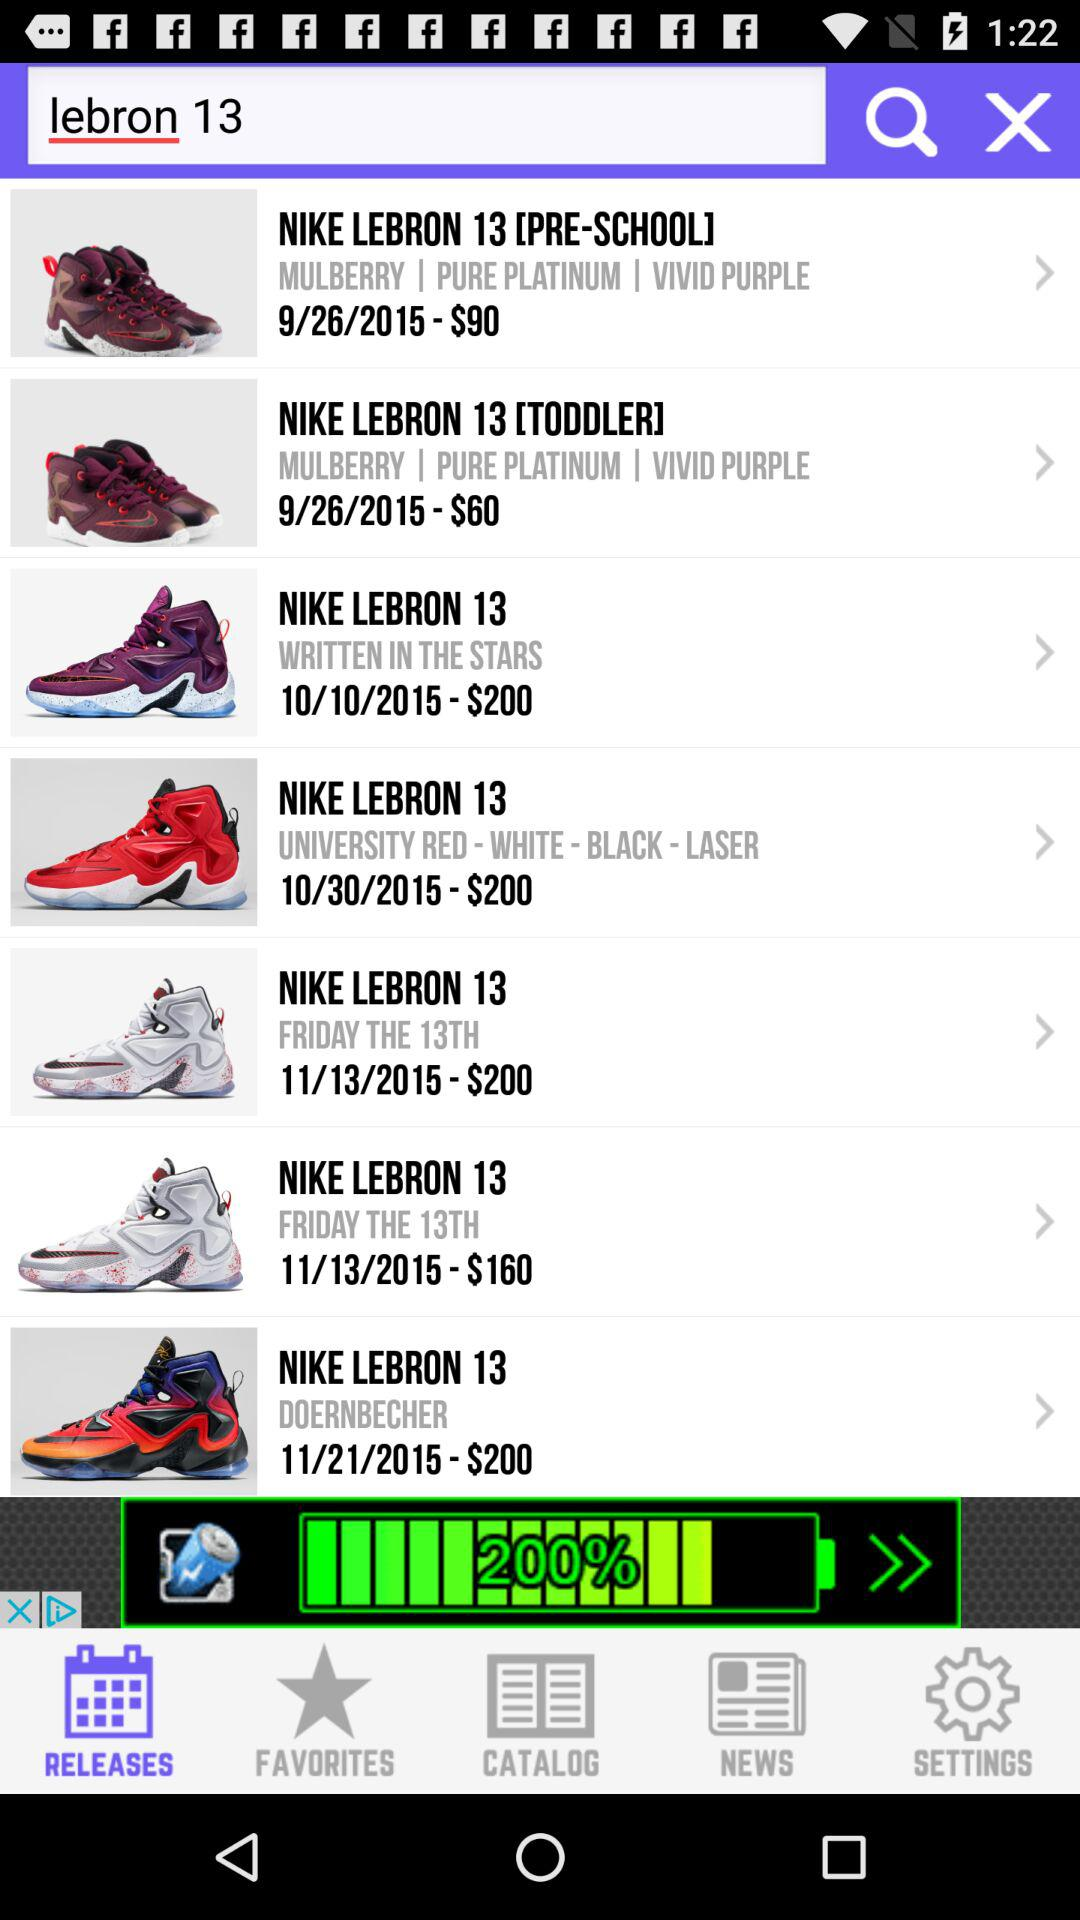Which tab has been chosen? The chosen tab is "RELEASES". 